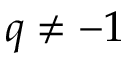Convert formula to latex. <formula><loc_0><loc_0><loc_500><loc_500>q \not = - 1</formula> 